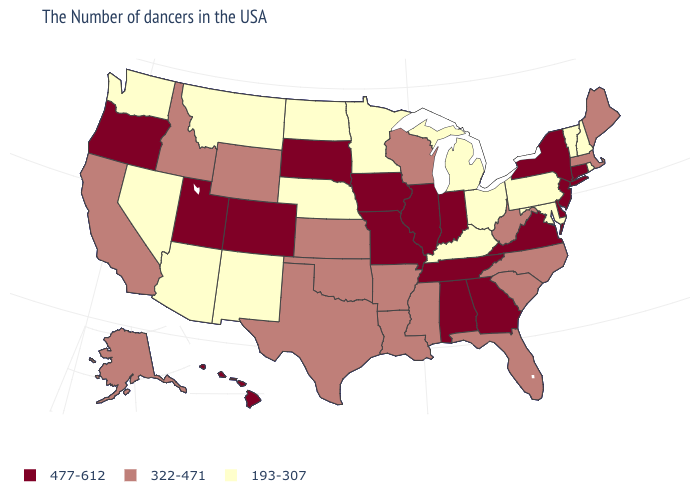Among the states that border Oregon , does Idaho have the highest value?
Short answer required. Yes. Name the states that have a value in the range 322-471?
Quick response, please. Maine, Massachusetts, North Carolina, South Carolina, West Virginia, Florida, Wisconsin, Mississippi, Louisiana, Arkansas, Kansas, Oklahoma, Texas, Wyoming, Idaho, California, Alaska. What is the value of South Carolina?
Quick response, please. 322-471. Among the states that border Massachusetts , which have the highest value?
Write a very short answer. Connecticut, New York. Among the states that border Arkansas , which have the highest value?
Concise answer only. Tennessee, Missouri. What is the highest value in the USA?
Write a very short answer. 477-612. Name the states that have a value in the range 193-307?
Answer briefly. Rhode Island, New Hampshire, Vermont, Maryland, Pennsylvania, Ohio, Michigan, Kentucky, Minnesota, Nebraska, North Dakota, New Mexico, Montana, Arizona, Nevada, Washington. Does Kentucky have the lowest value in the South?
Write a very short answer. Yes. Name the states that have a value in the range 193-307?
Short answer required. Rhode Island, New Hampshire, Vermont, Maryland, Pennsylvania, Ohio, Michigan, Kentucky, Minnesota, Nebraska, North Dakota, New Mexico, Montana, Arizona, Nevada, Washington. Which states have the highest value in the USA?
Concise answer only. Connecticut, New York, New Jersey, Delaware, Virginia, Georgia, Indiana, Alabama, Tennessee, Illinois, Missouri, Iowa, South Dakota, Colorado, Utah, Oregon, Hawaii. Does Alabama have the lowest value in the South?
Keep it brief. No. Does New Mexico have the lowest value in the USA?
Give a very brief answer. Yes. What is the lowest value in states that border Connecticut?
Answer briefly. 193-307. Which states have the lowest value in the MidWest?
Keep it brief. Ohio, Michigan, Minnesota, Nebraska, North Dakota. Name the states that have a value in the range 477-612?
Concise answer only. Connecticut, New York, New Jersey, Delaware, Virginia, Georgia, Indiana, Alabama, Tennessee, Illinois, Missouri, Iowa, South Dakota, Colorado, Utah, Oregon, Hawaii. 